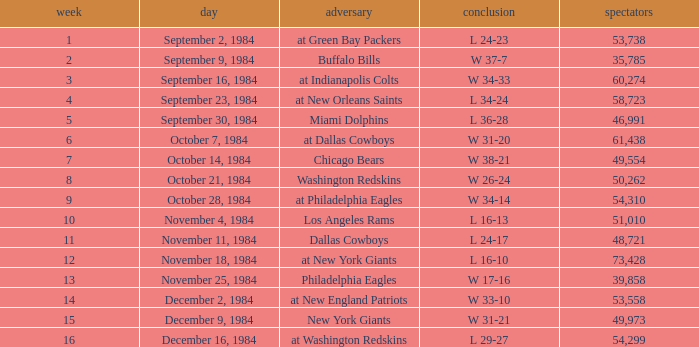What is the sum of attendance when the result was l 16-13? 51010.0. 